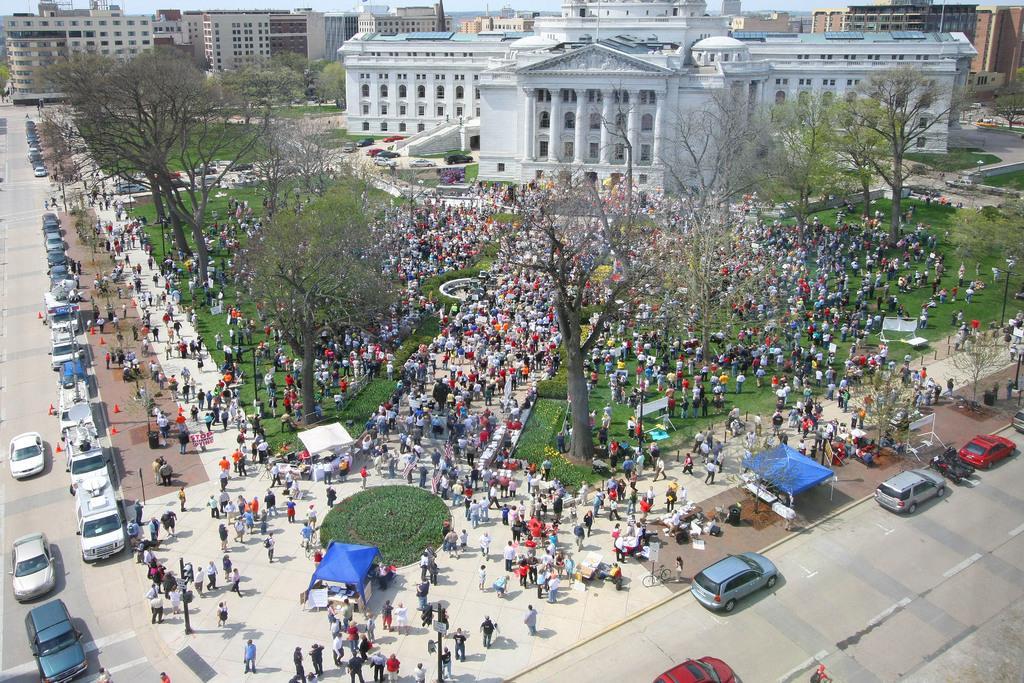Could you give a brief overview of what you see in this image? In the foreground of the image we can see the road, cars, some persons and grass. In the middle of the image we can see some persons are standing and trees are there. On the top of the image we can see the buildings. 